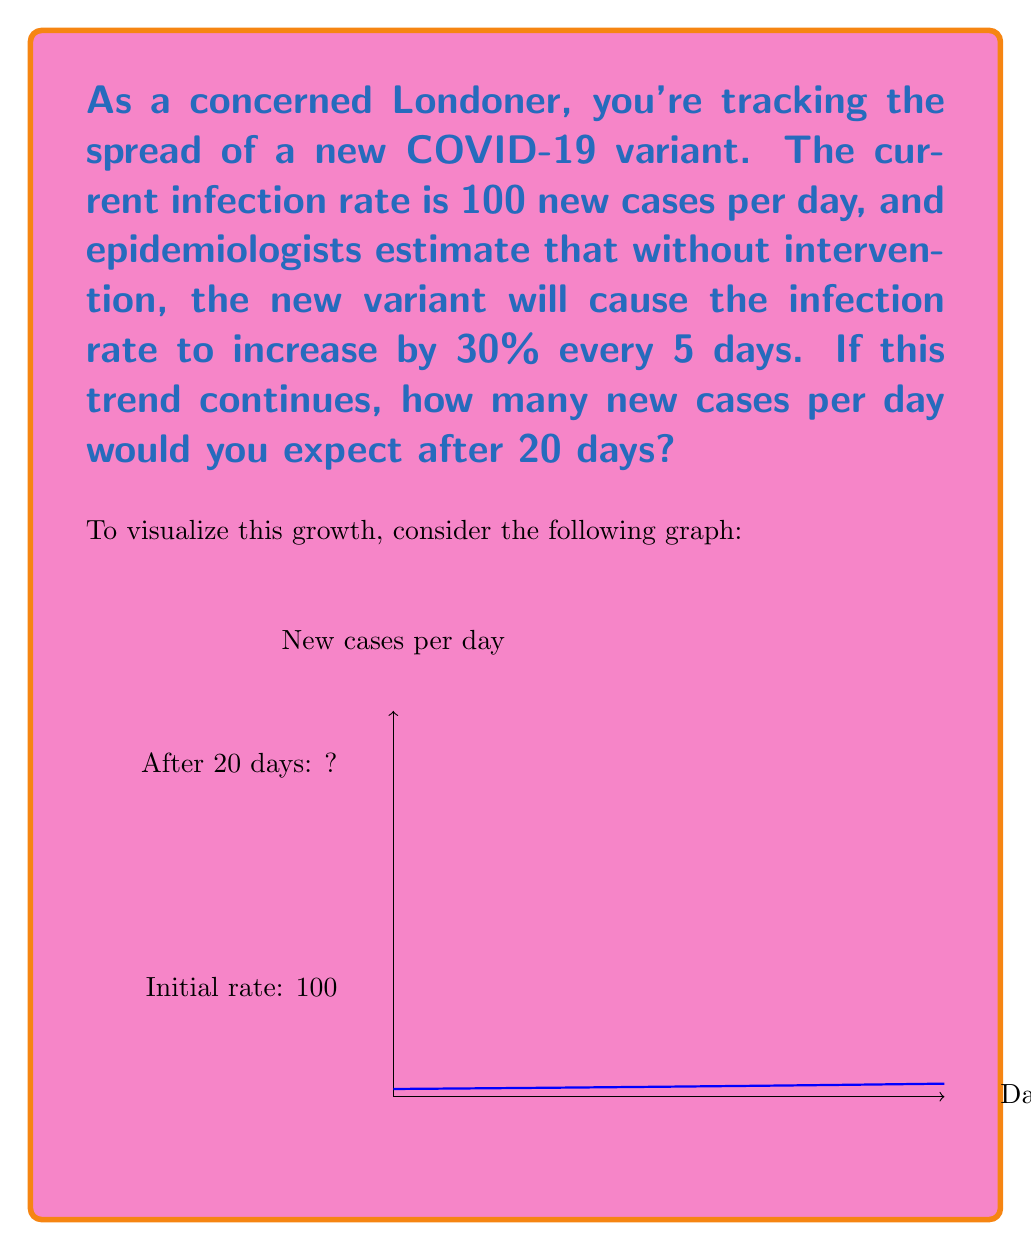Can you solve this math problem? Let's approach this step-by-step:

1) We start with an initial rate of 100 new cases per day.

2) The rate increases by 30% every 5 days. This means we multiply the rate by 1.3 every 5 days.

3) In 20 days, there are 4 periods of 5 days (20 ÷ 5 = 4).

4) So, we need to multiply the initial rate by 1.3 four times.

5) Mathematically, this can be expressed as:

   $$\text{New rate} = 100 \times (1.3)^4$$

6) Let's calculate this:
   $$\begin{align}
   100 \times (1.3)^4 &= 100 \times 2.8561
   \\ &= 285.61
   \end{align}$$

7) Rounding to the nearest whole number (as we can't have fractional new cases), we get 286.

This aligns with the exponential growth shown in the graph, where we can see the curve reaching just below 300 new cases per day at the 20-day mark.
Answer: 286 new cases per day 